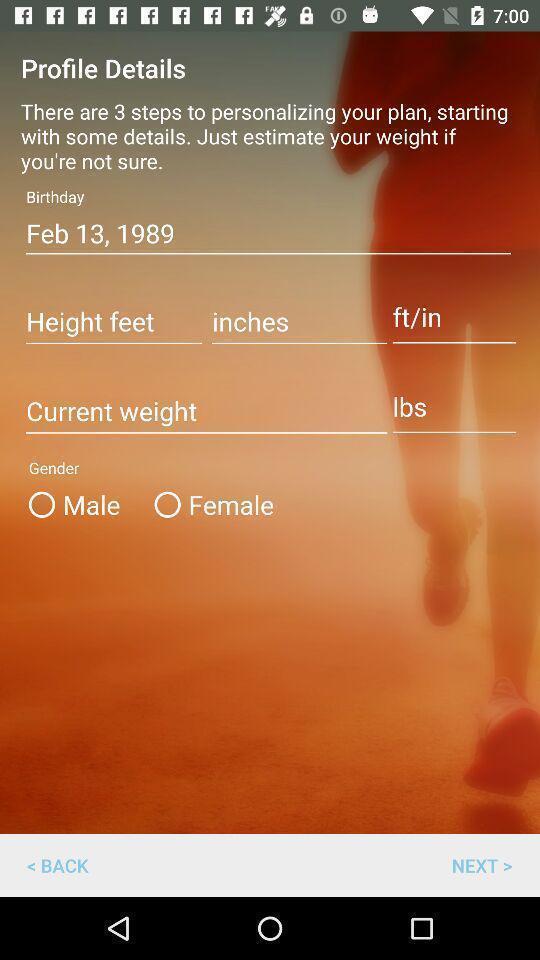Give me a summary of this screen capture. Screen displaying profile details on app. 